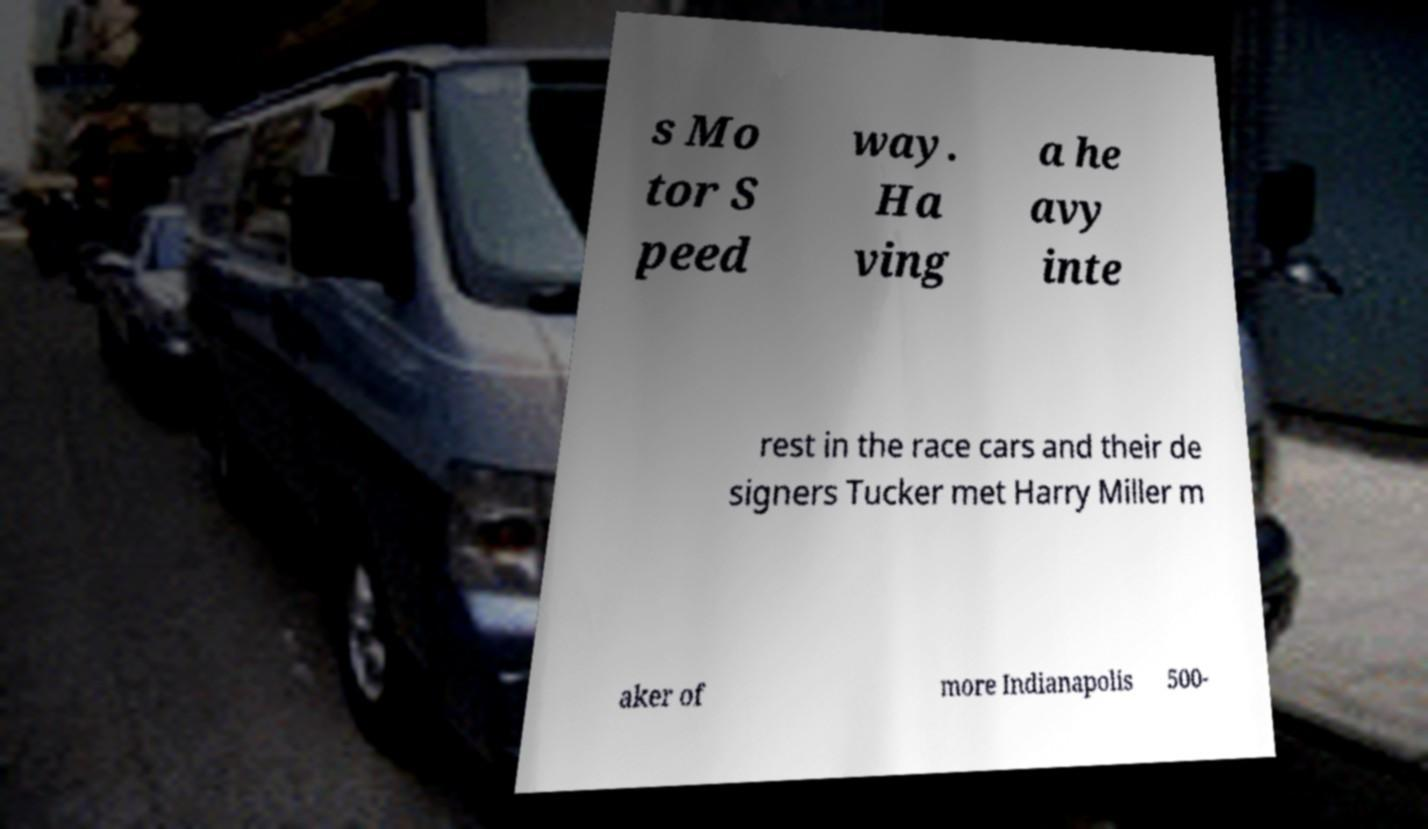Please identify and transcribe the text found in this image. s Mo tor S peed way. Ha ving a he avy inte rest in the race cars and their de signers Tucker met Harry Miller m aker of more Indianapolis 500- 